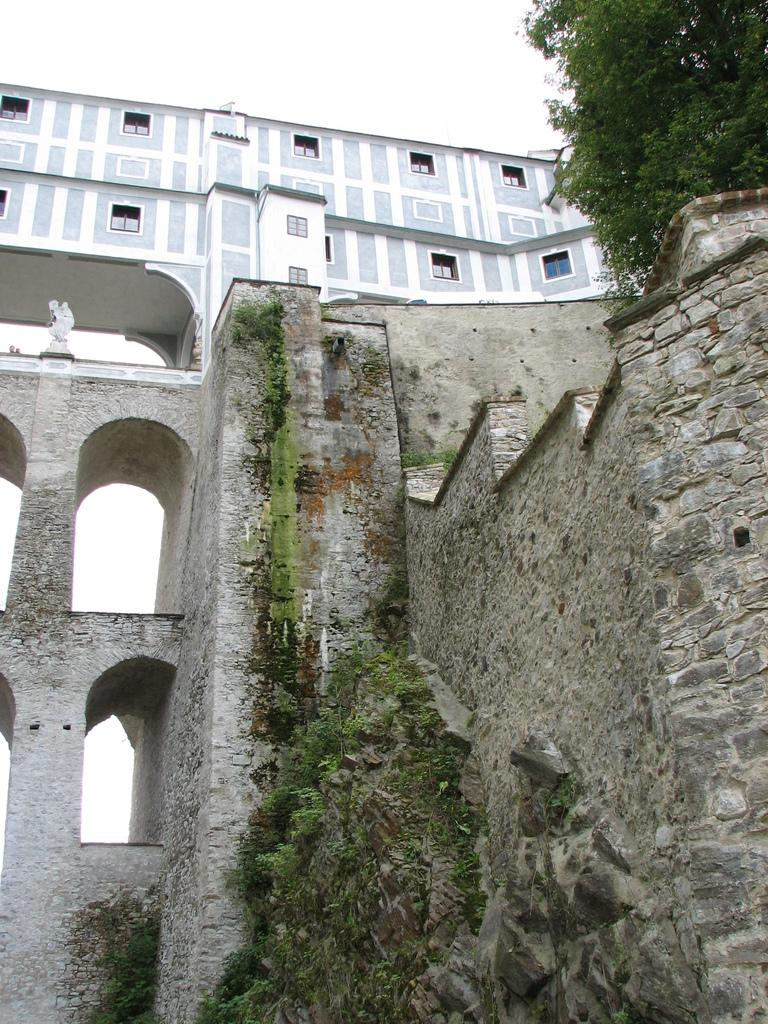What type of structure can be seen in the image? There is a building in the image. What is located near the building? There is a wall in the image. What type of vegetation is present in the image? There are trees in the image. What is the condition of the sky in the image? The sky is clear in the image. How many leaves are on the mask in the image? There is no mask or leaves present in the image. What type of ghost can be seen in the image? There is no ghost present in the image. 